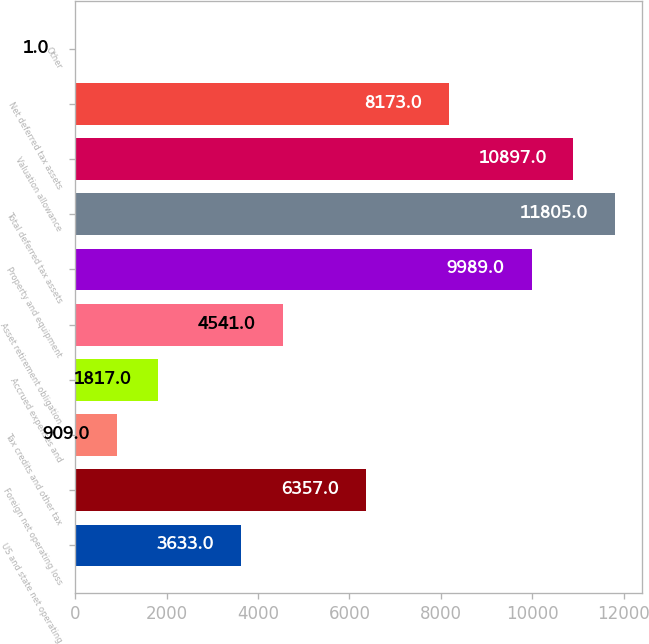Convert chart. <chart><loc_0><loc_0><loc_500><loc_500><bar_chart><fcel>US and state net operating<fcel>Foreign net operating loss<fcel>Tax credits and other tax<fcel>Accrued expenses and<fcel>Asset retirement obligation<fcel>Property and equipment<fcel>Total deferred tax assets<fcel>Valuation allowance<fcel>Net deferred tax assets<fcel>Other<nl><fcel>3633<fcel>6357<fcel>909<fcel>1817<fcel>4541<fcel>9989<fcel>11805<fcel>10897<fcel>8173<fcel>1<nl></chart> 